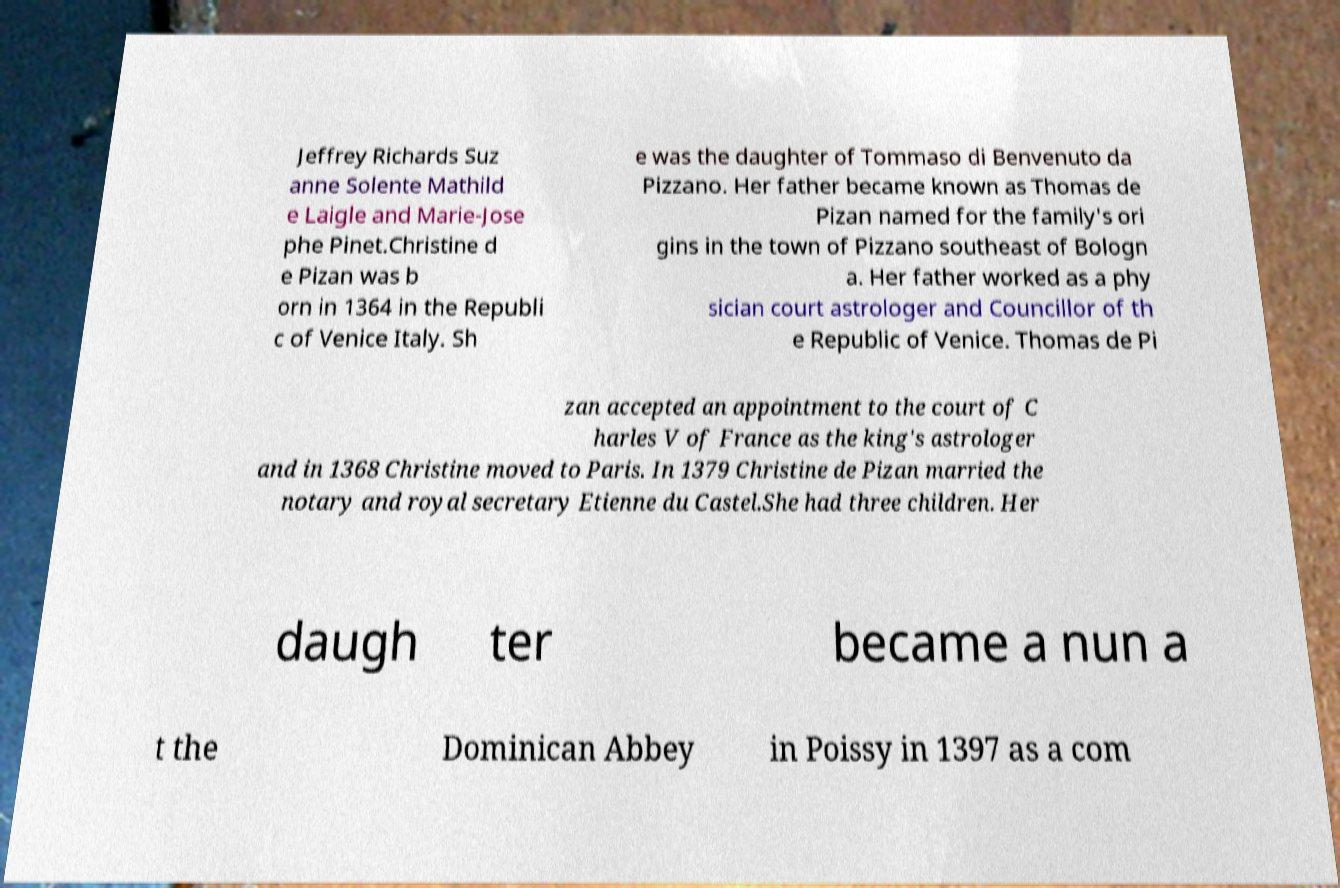Please identify and transcribe the text found in this image. Jeffrey Richards Suz anne Solente Mathild e Laigle and Marie-Jose phe Pinet.Christine d e Pizan was b orn in 1364 in the Republi c of Venice Italy. Sh e was the daughter of Tommaso di Benvenuto da Pizzano. Her father became known as Thomas de Pizan named for the family's ori gins in the town of Pizzano southeast of Bologn a. Her father worked as a phy sician court astrologer and Councillor of th e Republic of Venice. Thomas de Pi zan accepted an appointment to the court of C harles V of France as the king's astrologer and in 1368 Christine moved to Paris. In 1379 Christine de Pizan married the notary and royal secretary Etienne du Castel.She had three children. Her daugh ter became a nun a t the Dominican Abbey in Poissy in 1397 as a com 